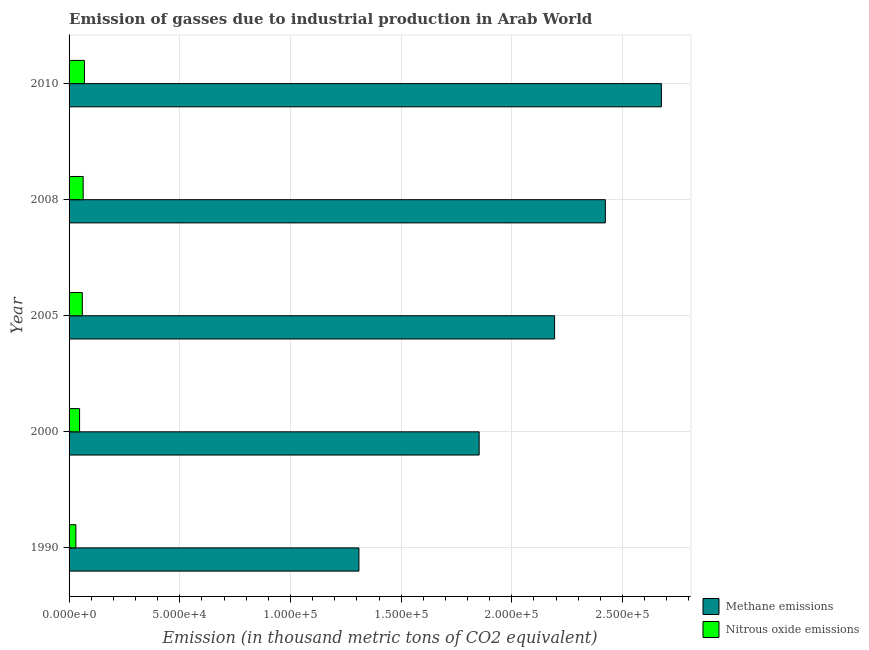Are the number of bars on each tick of the Y-axis equal?
Give a very brief answer. Yes. What is the label of the 3rd group of bars from the top?
Offer a very short reply. 2005. What is the amount of nitrous oxide emissions in 2010?
Keep it short and to the point. 6940.2. Across all years, what is the maximum amount of methane emissions?
Provide a succinct answer. 2.68e+05. Across all years, what is the minimum amount of nitrous oxide emissions?
Provide a succinct answer. 3077.4. In which year was the amount of methane emissions maximum?
Make the answer very short. 2010. In which year was the amount of nitrous oxide emissions minimum?
Give a very brief answer. 1990. What is the total amount of methane emissions in the graph?
Make the answer very short. 1.05e+06. What is the difference between the amount of nitrous oxide emissions in 2008 and that in 2010?
Ensure brevity in your answer.  -572.1. What is the difference between the amount of nitrous oxide emissions in 2005 and the amount of methane emissions in 1990?
Your answer should be very brief. -1.25e+05. What is the average amount of nitrous oxide emissions per year?
Offer a terse response. 5424.06. In the year 2010, what is the difference between the amount of nitrous oxide emissions and amount of methane emissions?
Provide a succinct answer. -2.61e+05. What is the ratio of the amount of methane emissions in 2005 to that in 2010?
Provide a short and direct response. 0.82. Is the difference between the amount of methane emissions in 2005 and 2010 greater than the difference between the amount of nitrous oxide emissions in 2005 and 2010?
Ensure brevity in your answer.  No. What is the difference between the highest and the second highest amount of methane emissions?
Offer a very short reply. 2.53e+04. What is the difference between the highest and the lowest amount of nitrous oxide emissions?
Your response must be concise. 3862.8. Is the sum of the amount of nitrous oxide emissions in 2000 and 2010 greater than the maximum amount of methane emissions across all years?
Provide a short and direct response. No. What does the 1st bar from the top in 2005 represents?
Ensure brevity in your answer.  Nitrous oxide emissions. What does the 2nd bar from the bottom in 2000 represents?
Your answer should be very brief. Nitrous oxide emissions. Does the graph contain grids?
Give a very brief answer. Yes. How are the legend labels stacked?
Give a very brief answer. Vertical. What is the title of the graph?
Your response must be concise. Emission of gasses due to industrial production in Arab World. What is the label or title of the X-axis?
Your answer should be compact. Emission (in thousand metric tons of CO2 equivalent). What is the label or title of the Y-axis?
Ensure brevity in your answer.  Year. What is the Emission (in thousand metric tons of CO2 equivalent) of Methane emissions in 1990?
Provide a short and direct response. 1.31e+05. What is the Emission (in thousand metric tons of CO2 equivalent) in Nitrous oxide emissions in 1990?
Give a very brief answer. 3077.4. What is the Emission (in thousand metric tons of CO2 equivalent) of Methane emissions in 2000?
Your answer should be very brief. 1.85e+05. What is the Emission (in thousand metric tons of CO2 equivalent) of Nitrous oxide emissions in 2000?
Give a very brief answer. 4745.5. What is the Emission (in thousand metric tons of CO2 equivalent) of Methane emissions in 2005?
Give a very brief answer. 2.19e+05. What is the Emission (in thousand metric tons of CO2 equivalent) in Nitrous oxide emissions in 2005?
Provide a succinct answer. 5989.1. What is the Emission (in thousand metric tons of CO2 equivalent) of Methane emissions in 2008?
Provide a succinct answer. 2.42e+05. What is the Emission (in thousand metric tons of CO2 equivalent) of Nitrous oxide emissions in 2008?
Your answer should be compact. 6368.1. What is the Emission (in thousand metric tons of CO2 equivalent) in Methane emissions in 2010?
Offer a terse response. 2.68e+05. What is the Emission (in thousand metric tons of CO2 equivalent) of Nitrous oxide emissions in 2010?
Provide a succinct answer. 6940.2. Across all years, what is the maximum Emission (in thousand metric tons of CO2 equivalent) of Methane emissions?
Keep it short and to the point. 2.68e+05. Across all years, what is the maximum Emission (in thousand metric tons of CO2 equivalent) in Nitrous oxide emissions?
Offer a terse response. 6940.2. Across all years, what is the minimum Emission (in thousand metric tons of CO2 equivalent) in Methane emissions?
Provide a succinct answer. 1.31e+05. Across all years, what is the minimum Emission (in thousand metric tons of CO2 equivalent) of Nitrous oxide emissions?
Keep it short and to the point. 3077.4. What is the total Emission (in thousand metric tons of CO2 equivalent) of Methane emissions in the graph?
Provide a succinct answer. 1.05e+06. What is the total Emission (in thousand metric tons of CO2 equivalent) in Nitrous oxide emissions in the graph?
Offer a very short reply. 2.71e+04. What is the difference between the Emission (in thousand metric tons of CO2 equivalent) of Methane emissions in 1990 and that in 2000?
Offer a very short reply. -5.43e+04. What is the difference between the Emission (in thousand metric tons of CO2 equivalent) in Nitrous oxide emissions in 1990 and that in 2000?
Offer a very short reply. -1668.1. What is the difference between the Emission (in thousand metric tons of CO2 equivalent) in Methane emissions in 1990 and that in 2005?
Your answer should be compact. -8.84e+04. What is the difference between the Emission (in thousand metric tons of CO2 equivalent) in Nitrous oxide emissions in 1990 and that in 2005?
Provide a succinct answer. -2911.7. What is the difference between the Emission (in thousand metric tons of CO2 equivalent) in Methane emissions in 1990 and that in 2008?
Ensure brevity in your answer.  -1.11e+05. What is the difference between the Emission (in thousand metric tons of CO2 equivalent) in Nitrous oxide emissions in 1990 and that in 2008?
Offer a terse response. -3290.7. What is the difference between the Emission (in thousand metric tons of CO2 equivalent) of Methane emissions in 1990 and that in 2010?
Your answer should be very brief. -1.37e+05. What is the difference between the Emission (in thousand metric tons of CO2 equivalent) in Nitrous oxide emissions in 1990 and that in 2010?
Provide a succinct answer. -3862.8. What is the difference between the Emission (in thousand metric tons of CO2 equivalent) of Methane emissions in 2000 and that in 2005?
Make the answer very short. -3.41e+04. What is the difference between the Emission (in thousand metric tons of CO2 equivalent) of Nitrous oxide emissions in 2000 and that in 2005?
Ensure brevity in your answer.  -1243.6. What is the difference between the Emission (in thousand metric tons of CO2 equivalent) of Methane emissions in 2000 and that in 2008?
Provide a succinct answer. -5.70e+04. What is the difference between the Emission (in thousand metric tons of CO2 equivalent) in Nitrous oxide emissions in 2000 and that in 2008?
Offer a terse response. -1622.6. What is the difference between the Emission (in thousand metric tons of CO2 equivalent) of Methane emissions in 2000 and that in 2010?
Keep it short and to the point. -8.23e+04. What is the difference between the Emission (in thousand metric tons of CO2 equivalent) of Nitrous oxide emissions in 2000 and that in 2010?
Offer a terse response. -2194.7. What is the difference between the Emission (in thousand metric tons of CO2 equivalent) of Methane emissions in 2005 and that in 2008?
Offer a terse response. -2.29e+04. What is the difference between the Emission (in thousand metric tons of CO2 equivalent) in Nitrous oxide emissions in 2005 and that in 2008?
Offer a very short reply. -379. What is the difference between the Emission (in thousand metric tons of CO2 equivalent) of Methane emissions in 2005 and that in 2010?
Provide a succinct answer. -4.82e+04. What is the difference between the Emission (in thousand metric tons of CO2 equivalent) of Nitrous oxide emissions in 2005 and that in 2010?
Offer a terse response. -951.1. What is the difference between the Emission (in thousand metric tons of CO2 equivalent) of Methane emissions in 2008 and that in 2010?
Your response must be concise. -2.53e+04. What is the difference between the Emission (in thousand metric tons of CO2 equivalent) in Nitrous oxide emissions in 2008 and that in 2010?
Offer a very short reply. -572.1. What is the difference between the Emission (in thousand metric tons of CO2 equivalent) of Methane emissions in 1990 and the Emission (in thousand metric tons of CO2 equivalent) of Nitrous oxide emissions in 2000?
Make the answer very short. 1.26e+05. What is the difference between the Emission (in thousand metric tons of CO2 equivalent) in Methane emissions in 1990 and the Emission (in thousand metric tons of CO2 equivalent) in Nitrous oxide emissions in 2005?
Give a very brief answer. 1.25e+05. What is the difference between the Emission (in thousand metric tons of CO2 equivalent) in Methane emissions in 1990 and the Emission (in thousand metric tons of CO2 equivalent) in Nitrous oxide emissions in 2008?
Keep it short and to the point. 1.25e+05. What is the difference between the Emission (in thousand metric tons of CO2 equivalent) of Methane emissions in 1990 and the Emission (in thousand metric tons of CO2 equivalent) of Nitrous oxide emissions in 2010?
Ensure brevity in your answer.  1.24e+05. What is the difference between the Emission (in thousand metric tons of CO2 equivalent) of Methane emissions in 2000 and the Emission (in thousand metric tons of CO2 equivalent) of Nitrous oxide emissions in 2005?
Keep it short and to the point. 1.79e+05. What is the difference between the Emission (in thousand metric tons of CO2 equivalent) of Methane emissions in 2000 and the Emission (in thousand metric tons of CO2 equivalent) of Nitrous oxide emissions in 2008?
Provide a succinct answer. 1.79e+05. What is the difference between the Emission (in thousand metric tons of CO2 equivalent) in Methane emissions in 2000 and the Emission (in thousand metric tons of CO2 equivalent) in Nitrous oxide emissions in 2010?
Give a very brief answer. 1.78e+05. What is the difference between the Emission (in thousand metric tons of CO2 equivalent) of Methane emissions in 2005 and the Emission (in thousand metric tons of CO2 equivalent) of Nitrous oxide emissions in 2008?
Your answer should be very brief. 2.13e+05. What is the difference between the Emission (in thousand metric tons of CO2 equivalent) in Methane emissions in 2005 and the Emission (in thousand metric tons of CO2 equivalent) in Nitrous oxide emissions in 2010?
Provide a succinct answer. 2.12e+05. What is the difference between the Emission (in thousand metric tons of CO2 equivalent) in Methane emissions in 2008 and the Emission (in thousand metric tons of CO2 equivalent) in Nitrous oxide emissions in 2010?
Your response must be concise. 2.35e+05. What is the average Emission (in thousand metric tons of CO2 equivalent) in Methane emissions per year?
Your answer should be very brief. 2.09e+05. What is the average Emission (in thousand metric tons of CO2 equivalent) in Nitrous oxide emissions per year?
Offer a terse response. 5424.06. In the year 1990, what is the difference between the Emission (in thousand metric tons of CO2 equivalent) of Methane emissions and Emission (in thousand metric tons of CO2 equivalent) of Nitrous oxide emissions?
Ensure brevity in your answer.  1.28e+05. In the year 2000, what is the difference between the Emission (in thousand metric tons of CO2 equivalent) in Methane emissions and Emission (in thousand metric tons of CO2 equivalent) in Nitrous oxide emissions?
Provide a short and direct response. 1.80e+05. In the year 2005, what is the difference between the Emission (in thousand metric tons of CO2 equivalent) of Methane emissions and Emission (in thousand metric tons of CO2 equivalent) of Nitrous oxide emissions?
Make the answer very short. 2.13e+05. In the year 2008, what is the difference between the Emission (in thousand metric tons of CO2 equivalent) in Methane emissions and Emission (in thousand metric tons of CO2 equivalent) in Nitrous oxide emissions?
Ensure brevity in your answer.  2.36e+05. In the year 2010, what is the difference between the Emission (in thousand metric tons of CO2 equivalent) of Methane emissions and Emission (in thousand metric tons of CO2 equivalent) of Nitrous oxide emissions?
Ensure brevity in your answer.  2.61e+05. What is the ratio of the Emission (in thousand metric tons of CO2 equivalent) of Methane emissions in 1990 to that in 2000?
Give a very brief answer. 0.71. What is the ratio of the Emission (in thousand metric tons of CO2 equivalent) of Nitrous oxide emissions in 1990 to that in 2000?
Your response must be concise. 0.65. What is the ratio of the Emission (in thousand metric tons of CO2 equivalent) in Methane emissions in 1990 to that in 2005?
Ensure brevity in your answer.  0.6. What is the ratio of the Emission (in thousand metric tons of CO2 equivalent) in Nitrous oxide emissions in 1990 to that in 2005?
Your answer should be compact. 0.51. What is the ratio of the Emission (in thousand metric tons of CO2 equivalent) in Methane emissions in 1990 to that in 2008?
Provide a short and direct response. 0.54. What is the ratio of the Emission (in thousand metric tons of CO2 equivalent) of Nitrous oxide emissions in 1990 to that in 2008?
Provide a succinct answer. 0.48. What is the ratio of the Emission (in thousand metric tons of CO2 equivalent) of Methane emissions in 1990 to that in 2010?
Provide a short and direct response. 0.49. What is the ratio of the Emission (in thousand metric tons of CO2 equivalent) in Nitrous oxide emissions in 1990 to that in 2010?
Give a very brief answer. 0.44. What is the ratio of the Emission (in thousand metric tons of CO2 equivalent) of Methane emissions in 2000 to that in 2005?
Provide a succinct answer. 0.84. What is the ratio of the Emission (in thousand metric tons of CO2 equivalent) in Nitrous oxide emissions in 2000 to that in 2005?
Your response must be concise. 0.79. What is the ratio of the Emission (in thousand metric tons of CO2 equivalent) in Methane emissions in 2000 to that in 2008?
Keep it short and to the point. 0.76. What is the ratio of the Emission (in thousand metric tons of CO2 equivalent) in Nitrous oxide emissions in 2000 to that in 2008?
Keep it short and to the point. 0.75. What is the ratio of the Emission (in thousand metric tons of CO2 equivalent) of Methane emissions in 2000 to that in 2010?
Ensure brevity in your answer.  0.69. What is the ratio of the Emission (in thousand metric tons of CO2 equivalent) in Nitrous oxide emissions in 2000 to that in 2010?
Your answer should be very brief. 0.68. What is the ratio of the Emission (in thousand metric tons of CO2 equivalent) of Methane emissions in 2005 to that in 2008?
Your answer should be very brief. 0.91. What is the ratio of the Emission (in thousand metric tons of CO2 equivalent) in Nitrous oxide emissions in 2005 to that in 2008?
Provide a short and direct response. 0.94. What is the ratio of the Emission (in thousand metric tons of CO2 equivalent) in Methane emissions in 2005 to that in 2010?
Offer a very short reply. 0.82. What is the ratio of the Emission (in thousand metric tons of CO2 equivalent) of Nitrous oxide emissions in 2005 to that in 2010?
Provide a short and direct response. 0.86. What is the ratio of the Emission (in thousand metric tons of CO2 equivalent) of Methane emissions in 2008 to that in 2010?
Keep it short and to the point. 0.91. What is the ratio of the Emission (in thousand metric tons of CO2 equivalent) of Nitrous oxide emissions in 2008 to that in 2010?
Your answer should be very brief. 0.92. What is the difference between the highest and the second highest Emission (in thousand metric tons of CO2 equivalent) in Methane emissions?
Keep it short and to the point. 2.53e+04. What is the difference between the highest and the second highest Emission (in thousand metric tons of CO2 equivalent) of Nitrous oxide emissions?
Your response must be concise. 572.1. What is the difference between the highest and the lowest Emission (in thousand metric tons of CO2 equivalent) of Methane emissions?
Your answer should be very brief. 1.37e+05. What is the difference between the highest and the lowest Emission (in thousand metric tons of CO2 equivalent) in Nitrous oxide emissions?
Make the answer very short. 3862.8. 